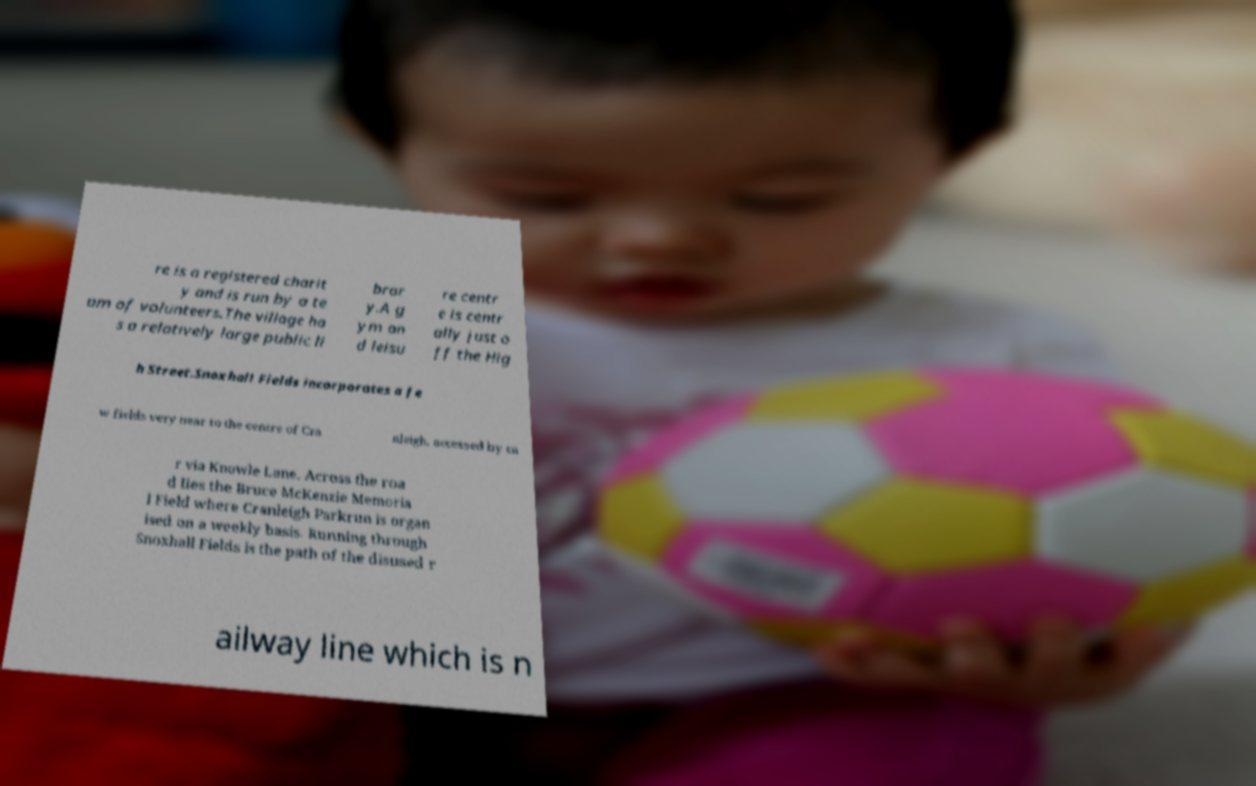Could you assist in decoding the text presented in this image and type it out clearly? re is a registered charit y and is run by a te am of volunteers.The village ha s a relatively large public li brar y.A g ym an d leisu re centr e is centr ally just o ff the Hig h Street.Snoxhall Fields incorporates a fe w fields very near to the centre of Cra nleigh, accessed by ca r via Knowle Lane. Across the roa d lies the Bruce McKenzie Memoria l Field where Cranleigh Parkrun is organ ised on a weekly basis. Running through Snoxhall Fields is the path of the disused r ailway line which is n 